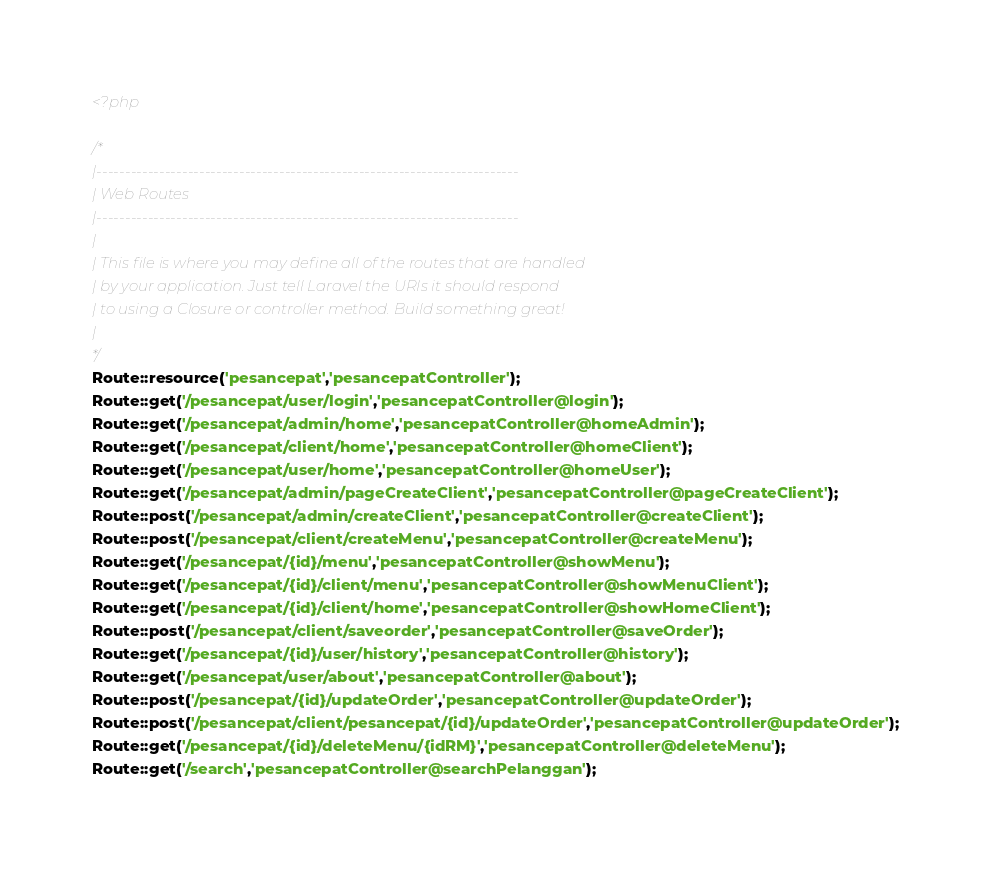<code> <loc_0><loc_0><loc_500><loc_500><_PHP_><?php

/*
|--------------------------------------------------------------------------
| Web Routes
|--------------------------------------------------------------------------
|
| This file is where you may define all of the routes that are handled
| by your application. Just tell Laravel the URIs it should respond
| to using a Closure or controller method. Build something great!
|
*/
Route::resource('pesancepat','pesancepatController');
Route::get('/pesancepat/user/login','pesancepatController@login');
Route::get('/pesancepat/admin/home','pesancepatController@homeAdmin');
Route::get('/pesancepat/client/home','pesancepatController@homeClient');
Route::get('/pesancepat/user/home','pesancepatController@homeUser');
Route::get('/pesancepat/admin/pageCreateClient','pesancepatController@pageCreateClient');
Route::post('/pesancepat/admin/createClient','pesancepatController@createClient');
Route::post('/pesancepat/client/createMenu','pesancepatController@createMenu');
Route::get('/pesancepat/{id}/menu','pesancepatController@showMenu');
Route::get('/pesancepat/{id}/client/menu','pesancepatController@showMenuClient');
Route::get('/pesancepat/{id}/client/home','pesancepatController@showHomeClient');
Route::post('/pesancepat/client/saveorder','pesancepatController@saveOrder');
Route::get('/pesancepat/{id}/user/history','pesancepatController@history');
Route::get('/pesancepat/user/about','pesancepatController@about');
Route::post('/pesancepat/{id}/updateOrder','pesancepatController@updateOrder');
Route::post('/pesancepat/client/pesancepat/{id}/updateOrder','pesancepatController@updateOrder');
Route::get('/pesancepat/{id}/deleteMenu/{idRM}','pesancepatController@deleteMenu');
Route::get('/search','pesancepatController@searchPelanggan');</code> 